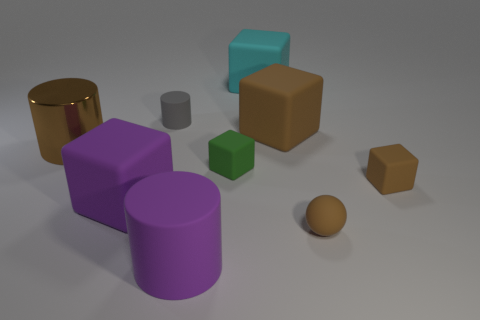Does the big rubber cylinder have the same color as the big shiny thing?
Your answer should be very brief. No. Does the purple cylinder have the same material as the small gray thing?
Keep it short and to the point. Yes. Are there any large brown rubber things that have the same shape as the gray object?
Provide a short and direct response. No. There is a large cylinder that is in front of the tiny sphere; is its color the same as the metal cylinder?
Offer a terse response. No. Is the size of the rubber cylinder that is behind the small green thing the same as the brown matte block behind the green matte object?
Make the answer very short. No. There is a purple block that is made of the same material as the sphere; what size is it?
Provide a succinct answer. Large. What number of things are left of the purple cylinder and to the right of the tiny rubber sphere?
Give a very brief answer. 0. What number of objects are either big brown rubber objects or objects in front of the gray thing?
Offer a terse response. 7. What is the shape of the large rubber thing that is the same color as the big matte cylinder?
Your answer should be very brief. Cube. What is the color of the tiny rubber block that is behind the tiny brown rubber block?
Provide a short and direct response. Green. 